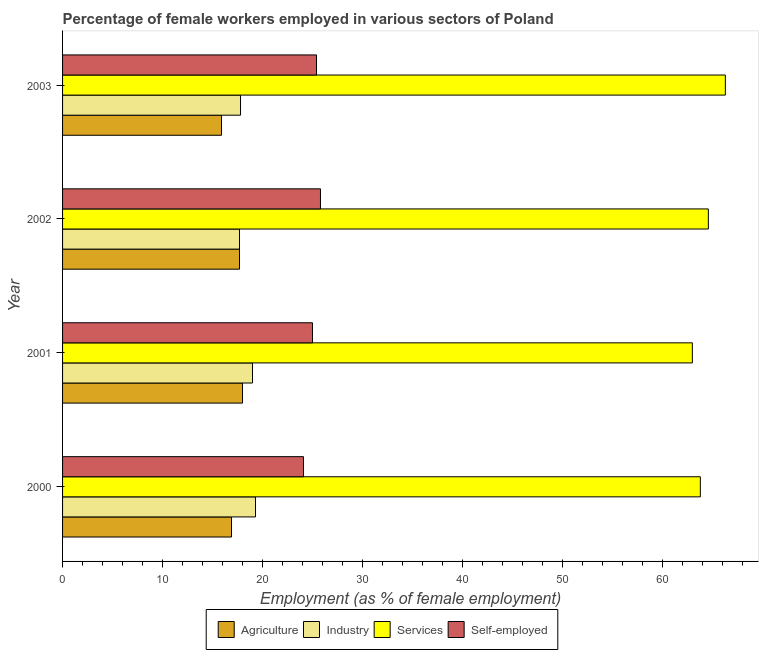Are the number of bars on each tick of the Y-axis equal?
Keep it short and to the point. Yes. How many bars are there on the 2nd tick from the top?
Provide a succinct answer. 4. In how many cases, is the number of bars for a given year not equal to the number of legend labels?
Offer a terse response. 0. What is the percentage of female workers in industry in 2000?
Your answer should be very brief. 19.3. Across all years, what is the maximum percentage of female workers in industry?
Your response must be concise. 19.3. Across all years, what is the minimum percentage of female workers in agriculture?
Provide a short and direct response. 15.9. In which year was the percentage of female workers in industry maximum?
Ensure brevity in your answer.  2000. In which year was the percentage of self employed female workers minimum?
Make the answer very short. 2000. What is the total percentage of female workers in industry in the graph?
Keep it short and to the point. 73.8. What is the difference between the percentage of female workers in industry in 2002 and that in 2003?
Offer a terse response. -0.1. What is the difference between the percentage of female workers in industry in 2003 and the percentage of female workers in services in 2001?
Keep it short and to the point. -45.2. What is the average percentage of female workers in agriculture per year?
Offer a very short reply. 17.12. What is the ratio of the percentage of female workers in services in 2002 to that in 2003?
Provide a short and direct response. 0.97. Is the percentage of female workers in services in 2001 less than that in 2002?
Give a very brief answer. Yes. Is the difference between the percentage of female workers in agriculture in 2001 and 2002 greater than the difference between the percentage of female workers in services in 2001 and 2002?
Provide a short and direct response. Yes. What is the difference between the highest and the second highest percentage of female workers in industry?
Give a very brief answer. 0.3. In how many years, is the percentage of female workers in agriculture greater than the average percentage of female workers in agriculture taken over all years?
Offer a very short reply. 2. Is the sum of the percentage of self employed female workers in 2000 and 2002 greater than the maximum percentage of female workers in services across all years?
Ensure brevity in your answer.  No. What does the 2nd bar from the top in 2003 represents?
Provide a succinct answer. Services. What does the 3rd bar from the bottom in 2003 represents?
Offer a terse response. Services. Is it the case that in every year, the sum of the percentage of female workers in agriculture and percentage of female workers in industry is greater than the percentage of female workers in services?
Make the answer very short. No. How many years are there in the graph?
Make the answer very short. 4. What is the difference between two consecutive major ticks on the X-axis?
Your answer should be very brief. 10. Are the values on the major ticks of X-axis written in scientific E-notation?
Provide a succinct answer. No. How many legend labels are there?
Provide a succinct answer. 4. How are the legend labels stacked?
Your answer should be very brief. Horizontal. What is the title of the graph?
Your answer should be compact. Percentage of female workers employed in various sectors of Poland. Does "Iceland" appear as one of the legend labels in the graph?
Give a very brief answer. No. What is the label or title of the X-axis?
Keep it short and to the point. Employment (as % of female employment). What is the Employment (as % of female employment) of Agriculture in 2000?
Provide a short and direct response. 16.9. What is the Employment (as % of female employment) in Industry in 2000?
Ensure brevity in your answer.  19.3. What is the Employment (as % of female employment) of Services in 2000?
Your answer should be compact. 63.8. What is the Employment (as % of female employment) of Self-employed in 2000?
Make the answer very short. 24.1. What is the Employment (as % of female employment) of Industry in 2001?
Keep it short and to the point. 19. What is the Employment (as % of female employment) of Self-employed in 2001?
Ensure brevity in your answer.  25. What is the Employment (as % of female employment) of Agriculture in 2002?
Give a very brief answer. 17.7. What is the Employment (as % of female employment) in Industry in 2002?
Ensure brevity in your answer.  17.7. What is the Employment (as % of female employment) of Services in 2002?
Your response must be concise. 64.6. What is the Employment (as % of female employment) of Self-employed in 2002?
Your response must be concise. 25.8. What is the Employment (as % of female employment) in Agriculture in 2003?
Offer a terse response. 15.9. What is the Employment (as % of female employment) of Industry in 2003?
Give a very brief answer. 17.8. What is the Employment (as % of female employment) of Services in 2003?
Give a very brief answer. 66.3. What is the Employment (as % of female employment) in Self-employed in 2003?
Keep it short and to the point. 25.4. Across all years, what is the maximum Employment (as % of female employment) in Industry?
Your response must be concise. 19.3. Across all years, what is the maximum Employment (as % of female employment) in Services?
Offer a terse response. 66.3. Across all years, what is the maximum Employment (as % of female employment) of Self-employed?
Offer a terse response. 25.8. Across all years, what is the minimum Employment (as % of female employment) in Agriculture?
Your answer should be very brief. 15.9. Across all years, what is the minimum Employment (as % of female employment) of Industry?
Offer a terse response. 17.7. Across all years, what is the minimum Employment (as % of female employment) in Services?
Offer a terse response. 63. Across all years, what is the minimum Employment (as % of female employment) of Self-employed?
Keep it short and to the point. 24.1. What is the total Employment (as % of female employment) of Agriculture in the graph?
Provide a short and direct response. 68.5. What is the total Employment (as % of female employment) in Industry in the graph?
Offer a very short reply. 73.8. What is the total Employment (as % of female employment) in Services in the graph?
Provide a short and direct response. 257.7. What is the total Employment (as % of female employment) in Self-employed in the graph?
Offer a terse response. 100.3. What is the difference between the Employment (as % of female employment) in Agriculture in 2000 and that in 2001?
Your response must be concise. -1.1. What is the difference between the Employment (as % of female employment) of Industry in 2000 and that in 2001?
Your answer should be very brief. 0.3. What is the difference between the Employment (as % of female employment) of Self-employed in 2000 and that in 2001?
Your answer should be very brief. -0.9. What is the difference between the Employment (as % of female employment) in Industry in 2000 and that in 2002?
Provide a succinct answer. 1.6. What is the difference between the Employment (as % of female employment) in Self-employed in 2000 and that in 2002?
Offer a very short reply. -1.7. What is the difference between the Employment (as % of female employment) of Agriculture in 2000 and that in 2003?
Provide a succinct answer. 1. What is the difference between the Employment (as % of female employment) in Industry in 2000 and that in 2003?
Provide a short and direct response. 1.5. What is the difference between the Employment (as % of female employment) of Services in 2000 and that in 2003?
Your answer should be compact. -2.5. What is the difference between the Employment (as % of female employment) of Self-employed in 2000 and that in 2003?
Your answer should be very brief. -1.3. What is the difference between the Employment (as % of female employment) of Industry in 2001 and that in 2002?
Keep it short and to the point. 1.3. What is the difference between the Employment (as % of female employment) in Services in 2001 and that in 2002?
Provide a short and direct response. -1.6. What is the difference between the Employment (as % of female employment) of Self-employed in 2001 and that in 2002?
Provide a short and direct response. -0.8. What is the difference between the Employment (as % of female employment) of Services in 2001 and that in 2003?
Make the answer very short. -3.3. What is the difference between the Employment (as % of female employment) of Agriculture in 2002 and that in 2003?
Your response must be concise. 1.8. What is the difference between the Employment (as % of female employment) in Services in 2002 and that in 2003?
Your answer should be compact. -1.7. What is the difference between the Employment (as % of female employment) in Self-employed in 2002 and that in 2003?
Keep it short and to the point. 0.4. What is the difference between the Employment (as % of female employment) of Agriculture in 2000 and the Employment (as % of female employment) of Industry in 2001?
Offer a terse response. -2.1. What is the difference between the Employment (as % of female employment) of Agriculture in 2000 and the Employment (as % of female employment) of Services in 2001?
Provide a short and direct response. -46.1. What is the difference between the Employment (as % of female employment) in Industry in 2000 and the Employment (as % of female employment) in Services in 2001?
Make the answer very short. -43.7. What is the difference between the Employment (as % of female employment) in Services in 2000 and the Employment (as % of female employment) in Self-employed in 2001?
Your response must be concise. 38.8. What is the difference between the Employment (as % of female employment) of Agriculture in 2000 and the Employment (as % of female employment) of Industry in 2002?
Make the answer very short. -0.8. What is the difference between the Employment (as % of female employment) of Agriculture in 2000 and the Employment (as % of female employment) of Services in 2002?
Provide a succinct answer. -47.7. What is the difference between the Employment (as % of female employment) in Industry in 2000 and the Employment (as % of female employment) in Services in 2002?
Keep it short and to the point. -45.3. What is the difference between the Employment (as % of female employment) in Services in 2000 and the Employment (as % of female employment) in Self-employed in 2002?
Offer a terse response. 38. What is the difference between the Employment (as % of female employment) in Agriculture in 2000 and the Employment (as % of female employment) in Industry in 2003?
Make the answer very short. -0.9. What is the difference between the Employment (as % of female employment) in Agriculture in 2000 and the Employment (as % of female employment) in Services in 2003?
Your answer should be compact. -49.4. What is the difference between the Employment (as % of female employment) in Agriculture in 2000 and the Employment (as % of female employment) in Self-employed in 2003?
Make the answer very short. -8.5. What is the difference between the Employment (as % of female employment) of Industry in 2000 and the Employment (as % of female employment) of Services in 2003?
Make the answer very short. -47. What is the difference between the Employment (as % of female employment) in Services in 2000 and the Employment (as % of female employment) in Self-employed in 2003?
Give a very brief answer. 38.4. What is the difference between the Employment (as % of female employment) of Agriculture in 2001 and the Employment (as % of female employment) of Industry in 2002?
Give a very brief answer. 0.3. What is the difference between the Employment (as % of female employment) in Agriculture in 2001 and the Employment (as % of female employment) in Services in 2002?
Make the answer very short. -46.6. What is the difference between the Employment (as % of female employment) of Industry in 2001 and the Employment (as % of female employment) of Services in 2002?
Your response must be concise. -45.6. What is the difference between the Employment (as % of female employment) in Services in 2001 and the Employment (as % of female employment) in Self-employed in 2002?
Offer a terse response. 37.2. What is the difference between the Employment (as % of female employment) of Agriculture in 2001 and the Employment (as % of female employment) of Industry in 2003?
Offer a very short reply. 0.2. What is the difference between the Employment (as % of female employment) in Agriculture in 2001 and the Employment (as % of female employment) in Services in 2003?
Your response must be concise. -48.3. What is the difference between the Employment (as % of female employment) in Agriculture in 2001 and the Employment (as % of female employment) in Self-employed in 2003?
Make the answer very short. -7.4. What is the difference between the Employment (as % of female employment) in Industry in 2001 and the Employment (as % of female employment) in Services in 2003?
Make the answer very short. -47.3. What is the difference between the Employment (as % of female employment) in Industry in 2001 and the Employment (as % of female employment) in Self-employed in 2003?
Your answer should be compact. -6.4. What is the difference between the Employment (as % of female employment) of Services in 2001 and the Employment (as % of female employment) of Self-employed in 2003?
Provide a succinct answer. 37.6. What is the difference between the Employment (as % of female employment) of Agriculture in 2002 and the Employment (as % of female employment) of Services in 2003?
Offer a terse response. -48.6. What is the difference between the Employment (as % of female employment) in Agriculture in 2002 and the Employment (as % of female employment) in Self-employed in 2003?
Your answer should be compact. -7.7. What is the difference between the Employment (as % of female employment) of Industry in 2002 and the Employment (as % of female employment) of Services in 2003?
Provide a succinct answer. -48.6. What is the difference between the Employment (as % of female employment) in Services in 2002 and the Employment (as % of female employment) in Self-employed in 2003?
Ensure brevity in your answer.  39.2. What is the average Employment (as % of female employment) in Agriculture per year?
Make the answer very short. 17.12. What is the average Employment (as % of female employment) of Industry per year?
Give a very brief answer. 18.45. What is the average Employment (as % of female employment) of Services per year?
Make the answer very short. 64.42. What is the average Employment (as % of female employment) in Self-employed per year?
Make the answer very short. 25.07. In the year 2000, what is the difference between the Employment (as % of female employment) of Agriculture and Employment (as % of female employment) of Industry?
Keep it short and to the point. -2.4. In the year 2000, what is the difference between the Employment (as % of female employment) in Agriculture and Employment (as % of female employment) in Services?
Your answer should be compact. -46.9. In the year 2000, what is the difference between the Employment (as % of female employment) of Industry and Employment (as % of female employment) of Services?
Ensure brevity in your answer.  -44.5. In the year 2000, what is the difference between the Employment (as % of female employment) in Services and Employment (as % of female employment) in Self-employed?
Keep it short and to the point. 39.7. In the year 2001, what is the difference between the Employment (as % of female employment) of Agriculture and Employment (as % of female employment) of Industry?
Keep it short and to the point. -1. In the year 2001, what is the difference between the Employment (as % of female employment) in Agriculture and Employment (as % of female employment) in Services?
Give a very brief answer. -45. In the year 2001, what is the difference between the Employment (as % of female employment) in Agriculture and Employment (as % of female employment) in Self-employed?
Your answer should be very brief. -7. In the year 2001, what is the difference between the Employment (as % of female employment) in Industry and Employment (as % of female employment) in Services?
Your answer should be compact. -44. In the year 2002, what is the difference between the Employment (as % of female employment) in Agriculture and Employment (as % of female employment) in Services?
Your response must be concise. -46.9. In the year 2002, what is the difference between the Employment (as % of female employment) of Industry and Employment (as % of female employment) of Services?
Offer a terse response. -46.9. In the year 2002, what is the difference between the Employment (as % of female employment) in Services and Employment (as % of female employment) in Self-employed?
Your answer should be compact. 38.8. In the year 2003, what is the difference between the Employment (as % of female employment) of Agriculture and Employment (as % of female employment) of Services?
Give a very brief answer. -50.4. In the year 2003, what is the difference between the Employment (as % of female employment) in Agriculture and Employment (as % of female employment) in Self-employed?
Make the answer very short. -9.5. In the year 2003, what is the difference between the Employment (as % of female employment) of Industry and Employment (as % of female employment) of Services?
Offer a very short reply. -48.5. In the year 2003, what is the difference between the Employment (as % of female employment) in Services and Employment (as % of female employment) in Self-employed?
Your response must be concise. 40.9. What is the ratio of the Employment (as % of female employment) in Agriculture in 2000 to that in 2001?
Your answer should be compact. 0.94. What is the ratio of the Employment (as % of female employment) in Industry in 2000 to that in 2001?
Offer a terse response. 1.02. What is the ratio of the Employment (as % of female employment) in Services in 2000 to that in 2001?
Give a very brief answer. 1.01. What is the ratio of the Employment (as % of female employment) of Self-employed in 2000 to that in 2001?
Make the answer very short. 0.96. What is the ratio of the Employment (as % of female employment) of Agriculture in 2000 to that in 2002?
Ensure brevity in your answer.  0.95. What is the ratio of the Employment (as % of female employment) of Industry in 2000 to that in 2002?
Your answer should be compact. 1.09. What is the ratio of the Employment (as % of female employment) of Services in 2000 to that in 2002?
Offer a terse response. 0.99. What is the ratio of the Employment (as % of female employment) in Self-employed in 2000 to that in 2002?
Offer a very short reply. 0.93. What is the ratio of the Employment (as % of female employment) in Agriculture in 2000 to that in 2003?
Provide a succinct answer. 1.06. What is the ratio of the Employment (as % of female employment) of Industry in 2000 to that in 2003?
Offer a terse response. 1.08. What is the ratio of the Employment (as % of female employment) of Services in 2000 to that in 2003?
Keep it short and to the point. 0.96. What is the ratio of the Employment (as % of female employment) in Self-employed in 2000 to that in 2003?
Make the answer very short. 0.95. What is the ratio of the Employment (as % of female employment) of Agriculture in 2001 to that in 2002?
Offer a terse response. 1.02. What is the ratio of the Employment (as % of female employment) in Industry in 2001 to that in 2002?
Your response must be concise. 1.07. What is the ratio of the Employment (as % of female employment) of Services in 2001 to that in 2002?
Ensure brevity in your answer.  0.98. What is the ratio of the Employment (as % of female employment) in Self-employed in 2001 to that in 2002?
Provide a succinct answer. 0.97. What is the ratio of the Employment (as % of female employment) in Agriculture in 2001 to that in 2003?
Keep it short and to the point. 1.13. What is the ratio of the Employment (as % of female employment) of Industry in 2001 to that in 2003?
Your answer should be compact. 1.07. What is the ratio of the Employment (as % of female employment) in Services in 2001 to that in 2003?
Your answer should be compact. 0.95. What is the ratio of the Employment (as % of female employment) of Self-employed in 2001 to that in 2003?
Ensure brevity in your answer.  0.98. What is the ratio of the Employment (as % of female employment) in Agriculture in 2002 to that in 2003?
Keep it short and to the point. 1.11. What is the ratio of the Employment (as % of female employment) of Industry in 2002 to that in 2003?
Your answer should be very brief. 0.99. What is the ratio of the Employment (as % of female employment) in Services in 2002 to that in 2003?
Make the answer very short. 0.97. What is the ratio of the Employment (as % of female employment) in Self-employed in 2002 to that in 2003?
Offer a very short reply. 1.02. What is the difference between the highest and the second highest Employment (as % of female employment) in Industry?
Your answer should be compact. 0.3. What is the difference between the highest and the second highest Employment (as % of female employment) of Self-employed?
Provide a short and direct response. 0.4. What is the difference between the highest and the lowest Employment (as % of female employment) in Self-employed?
Give a very brief answer. 1.7. 